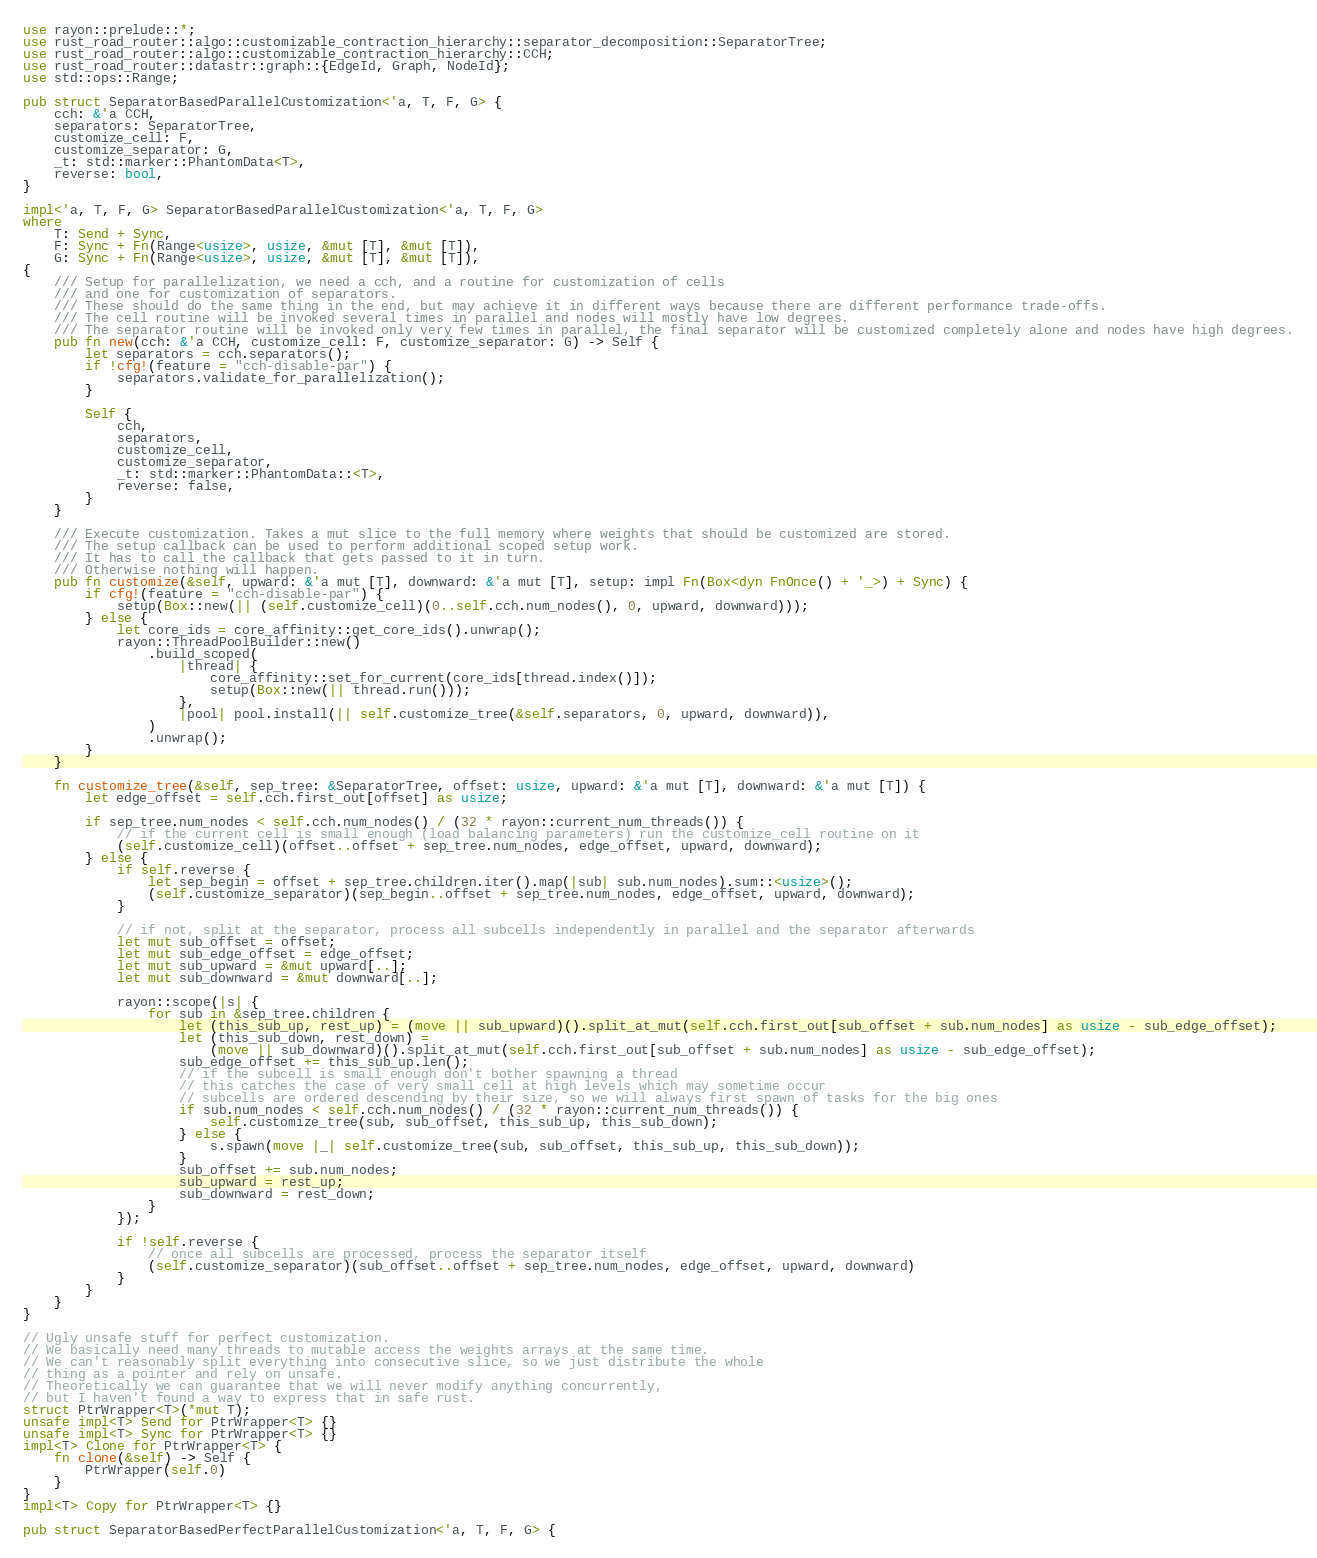<code> <loc_0><loc_0><loc_500><loc_500><_Rust_>use rayon::prelude::*;
use rust_road_router::algo::customizable_contraction_hierarchy::separator_decomposition::SeparatorTree;
use rust_road_router::algo::customizable_contraction_hierarchy::CCH;
use rust_road_router::datastr::graph::{EdgeId, Graph, NodeId};
use std::ops::Range;

pub struct SeparatorBasedParallelCustomization<'a, T, F, G> {
    cch: &'a CCH,
    separators: SeparatorTree,
    customize_cell: F,
    customize_separator: G,
    _t: std::marker::PhantomData<T>,
    reverse: bool,
}

impl<'a, T, F, G> SeparatorBasedParallelCustomization<'a, T, F, G>
where
    T: Send + Sync,
    F: Sync + Fn(Range<usize>, usize, &mut [T], &mut [T]),
    G: Sync + Fn(Range<usize>, usize, &mut [T], &mut [T]),
{
    /// Setup for parallelization, we need a cch, and a routine for customization of cells
    /// and one for customization of separators.
    /// These should do the same thing in the end, but may achieve it in different ways because there are different performance trade-offs.
    /// The cell routine will be invoked several times in parallel and nodes will mostly have low degrees.
    /// The separator routine will be invoked only very few times in parallel, the final separator will be customized completely alone and nodes have high degrees.
    pub fn new(cch: &'a CCH, customize_cell: F, customize_separator: G) -> Self {
        let separators = cch.separators();
        if !cfg!(feature = "cch-disable-par") {
            separators.validate_for_parallelization();
        }

        Self {
            cch,
            separators,
            customize_cell,
            customize_separator,
            _t: std::marker::PhantomData::<T>,
            reverse: false,
        }
    }

    /// Execute customization. Takes a mut slice to the full memory where weights that should be customized are stored.
    /// The setup callback can be used to perform additional scoped setup work.
    /// It has to call the callback that gets passed to it in turn.
    /// Otherwise nothing will happen.
    pub fn customize(&self, upward: &'a mut [T], downward: &'a mut [T], setup: impl Fn(Box<dyn FnOnce() + '_>) + Sync) {
        if cfg!(feature = "cch-disable-par") {
            setup(Box::new(|| (self.customize_cell)(0..self.cch.num_nodes(), 0, upward, downward)));
        } else {
            let core_ids = core_affinity::get_core_ids().unwrap();
            rayon::ThreadPoolBuilder::new()
                .build_scoped(
                    |thread| {
                        core_affinity::set_for_current(core_ids[thread.index()]);
                        setup(Box::new(|| thread.run()));
                    },
                    |pool| pool.install(|| self.customize_tree(&self.separators, 0, upward, downward)),
                )
                .unwrap();
        }
    }

    fn customize_tree(&self, sep_tree: &SeparatorTree, offset: usize, upward: &'a mut [T], downward: &'a mut [T]) {
        let edge_offset = self.cch.first_out[offset] as usize;

        if sep_tree.num_nodes < self.cch.num_nodes() / (32 * rayon::current_num_threads()) {
            // if the current cell is small enough (load balancing parameters) run the customize_cell routine on it
            (self.customize_cell)(offset..offset + sep_tree.num_nodes, edge_offset, upward, downward);
        } else {
            if self.reverse {
                let sep_begin = offset + sep_tree.children.iter().map(|sub| sub.num_nodes).sum::<usize>();
                (self.customize_separator)(sep_begin..offset + sep_tree.num_nodes, edge_offset, upward, downward);
            }

            // if not, split at the separator, process all subcells independently in parallel and the separator afterwards
            let mut sub_offset = offset;
            let mut sub_edge_offset = edge_offset;
            let mut sub_upward = &mut upward[..];
            let mut sub_downward = &mut downward[..];

            rayon::scope(|s| {
                for sub in &sep_tree.children {
                    let (this_sub_up, rest_up) = (move || sub_upward)().split_at_mut(self.cch.first_out[sub_offset + sub.num_nodes] as usize - sub_edge_offset);
                    let (this_sub_down, rest_down) =
                        (move || sub_downward)().split_at_mut(self.cch.first_out[sub_offset + sub.num_nodes] as usize - sub_edge_offset);
                    sub_edge_offset += this_sub_up.len();
                    // if the subcell is small enough don't bother spawning a thread
                    // this catches the case of very small cell at high levels which may sometime occur
                    // subcells are ordered descending by their size, so we will always first spawn of tasks for the big ones
                    if sub.num_nodes < self.cch.num_nodes() / (32 * rayon::current_num_threads()) {
                        self.customize_tree(sub, sub_offset, this_sub_up, this_sub_down);
                    } else {
                        s.spawn(move |_| self.customize_tree(sub, sub_offset, this_sub_up, this_sub_down));
                    }
                    sub_offset += sub.num_nodes;
                    sub_upward = rest_up;
                    sub_downward = rest_down;
                }
            });

            if !self.reverse {
                // once all subcells are processed, process the separator itself
                (self.customize_separator)(sub_offset..offset + sep_tree.num_nodes, edge_offset, upward, downward)
            }
        }
    }
}

// Ugly unsafe stuff for perfect customization.
// We basically need many threads to mutable access the weights arrays at the same time.
// We can't reasonably split everything into consecutive slice, so we just distribute the whole
// thing as a pointer and rely on unsafe.
// Theoretically we can guarantee that we will never modify anything concurrently,
// but I haven't found a way to express that in safe rust.
struct PtrWrapper<T>(*mut T);
unsafe impl<T> Send for PtrWrapper<T> {}
unsafe impl<T> Sync for PtrWrapper<T> {}
impl<T> Clone for PtrWrapper<T> {
    fn clone(&self) -> Self {
        PtrWrapper(self.0)
    }
}
impl<T> Copy for PtrWrapper<T> {}

pub struct SeparatorBasedPerfectParallelCustomization<'a, T, F, G> {</code> 